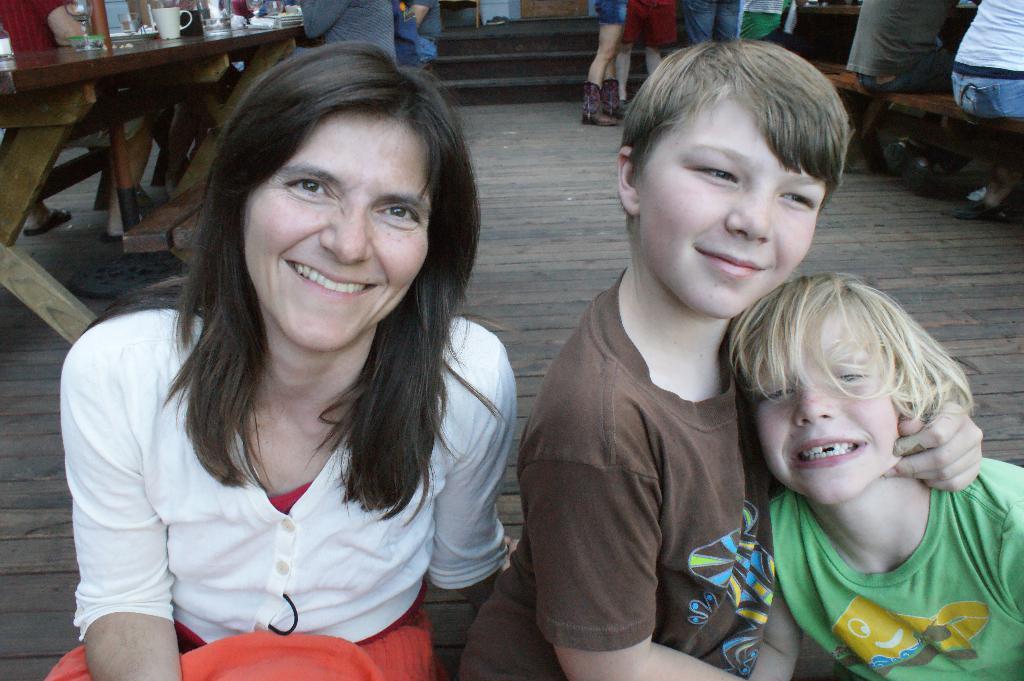Please provide a concise description of this image. In this image, we can see people wearing clothes. There is a table in the top left of the image contains cup and glass. There is a bench in the top right of the image. There are steps at the top of the image. 